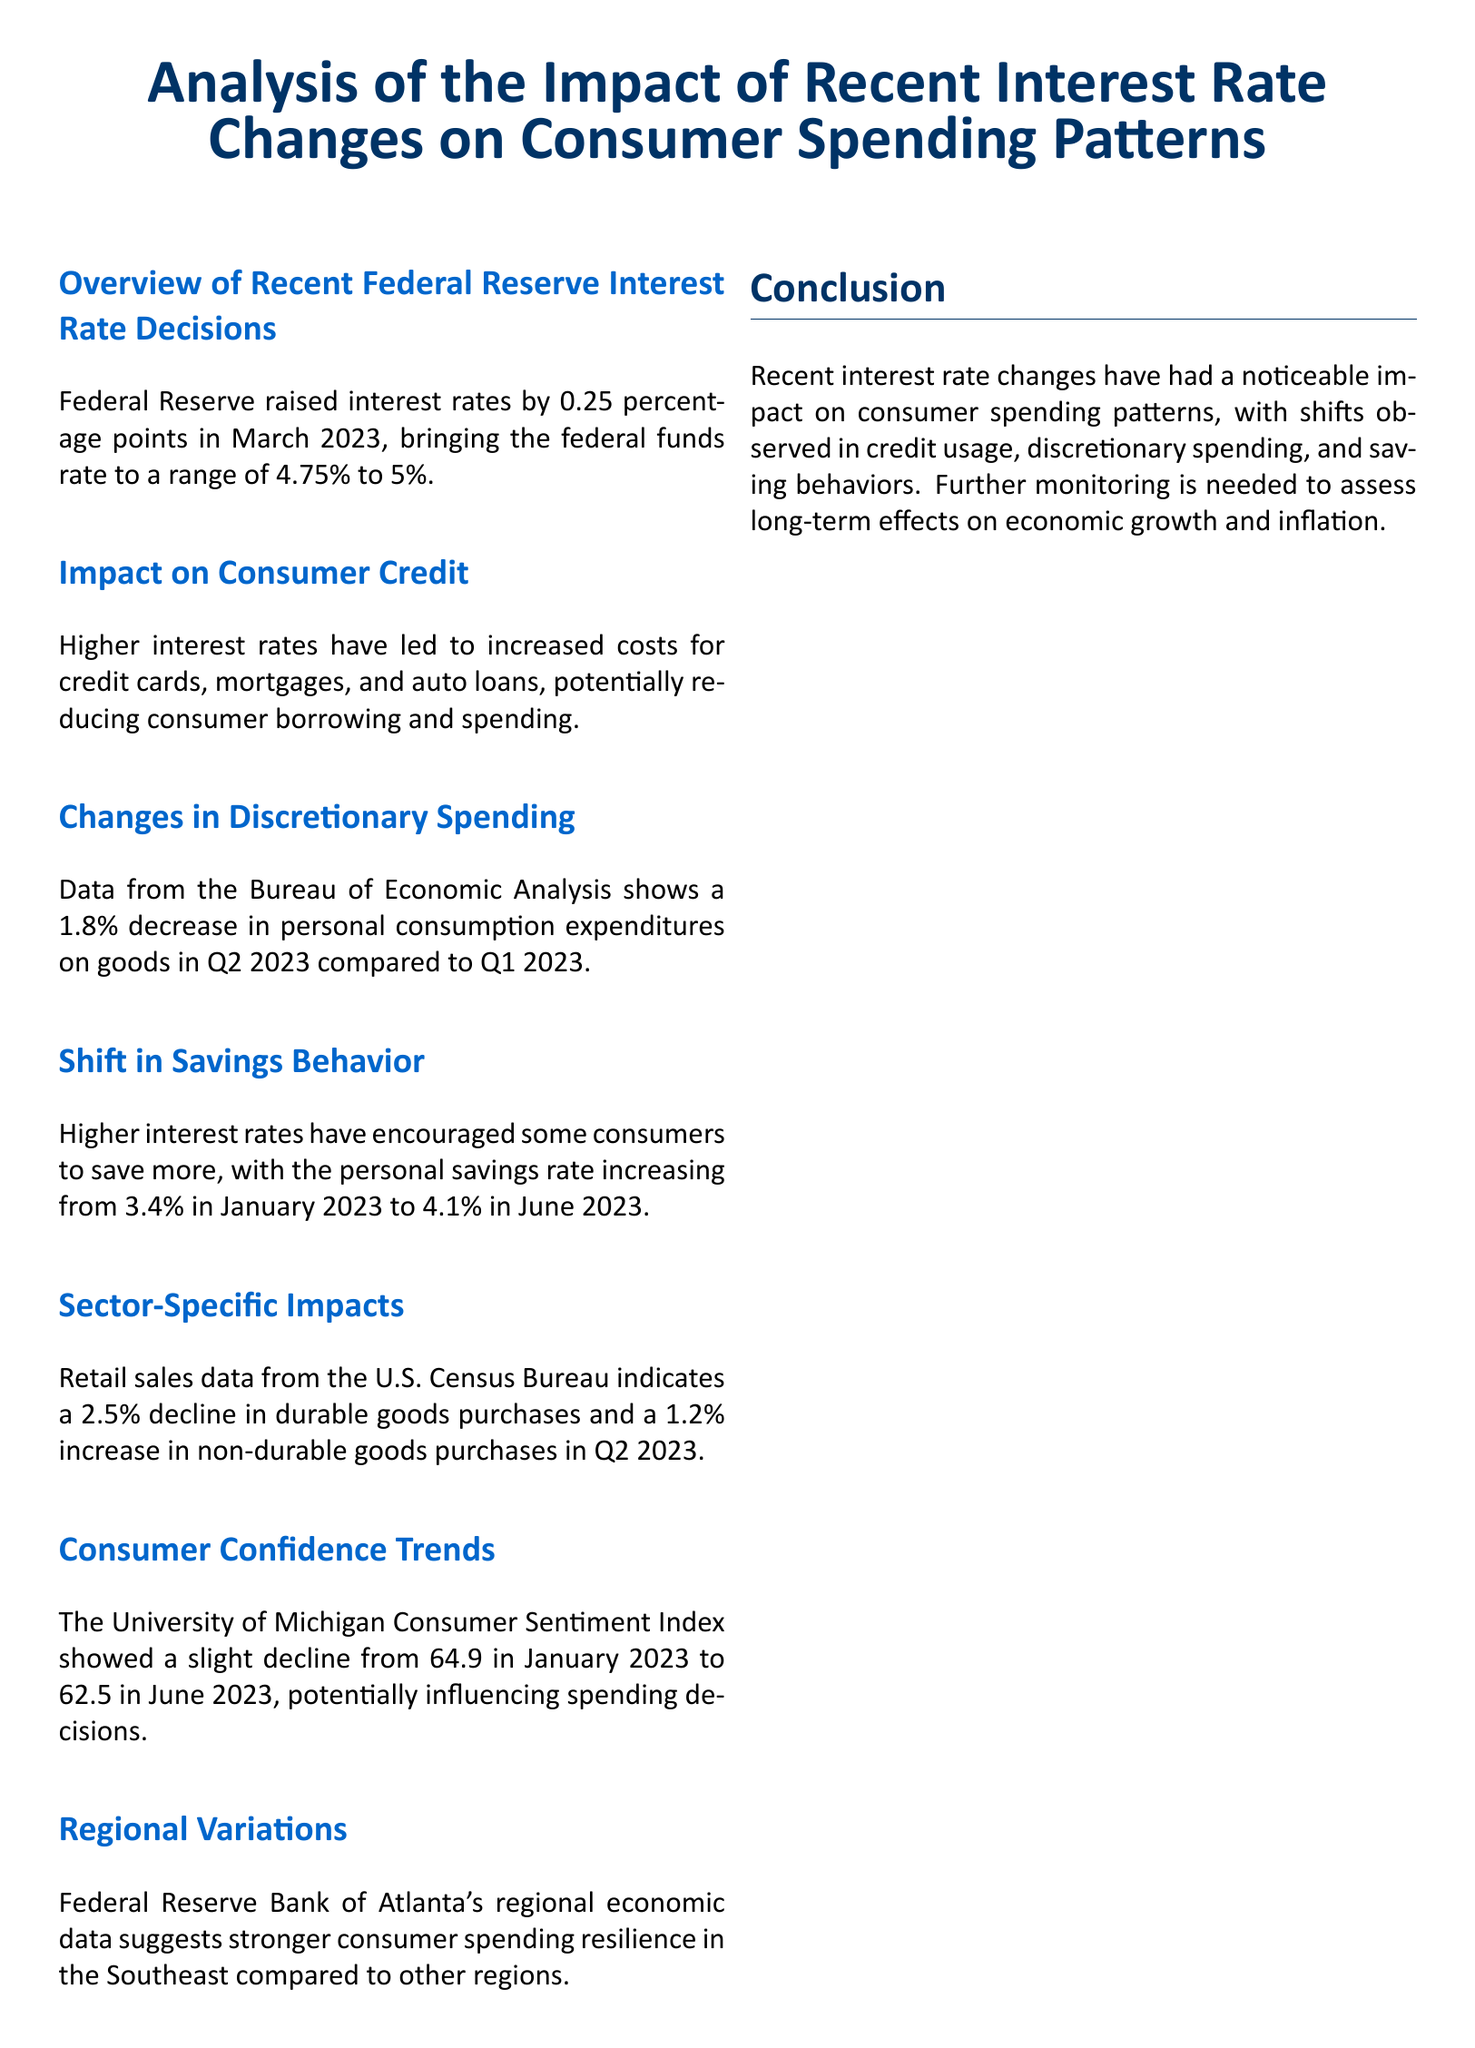What was the interest rate increase in March 2023? The Federal Reserve raised interest rates by 0.25 percentage points in March 2023.
Answer: 0.25 percentage points What is the current range of the federal funds rate? The document states that the current range of the federal funds rate is 4.75% to 5%.
Answer: 4.75% to 5% What percentage decrease occurred in personal consumption expenditures on goods in Q2 2023? The data shows a 1.8% decrease in personal consumption expenditures on goods in Q2 2023 compared to Q1 2023.
Answer: 1.8% By how much did the personal savings rate increase from January to June 2023? The personal savings rate increased from 3.4% in January 2023 to 4.1% in June 2023.
Answer: 0.7 percentage points What change was observed in durable goods purchases in Q2 2023? The retail sales data indicates a 2.5% decline in durable goods purchases in Q2 2023.
Answer: 2.5% decline What was the University of Michigan Consumer Sentiment Index in June 2023? The index showed a decline from 64.9 in January 2023 to 62.5 in June 2023.
Answer: 62.5 Which region showed stronger consumer spending resilience? The Federal Reserve Bank of Atlanta's data suggests stronger consumer spending resilience in the Southeast.
Answer: Southeast What trend is noted in consumer saving behavior due to higher interest rates? Higher interest rates have encouraged some consumers to save more.
Answer: Save more 